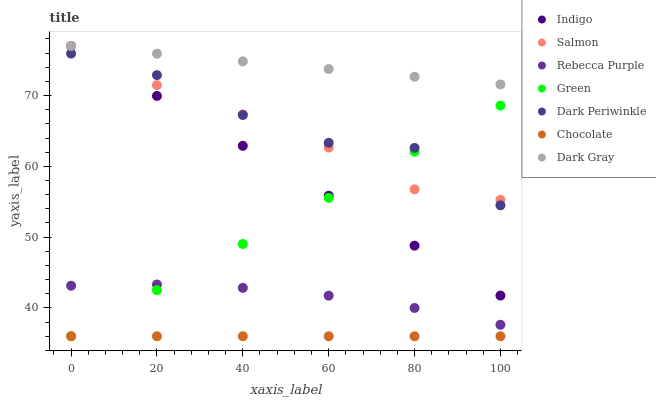Does Chocolate have the minimum area under the curve?
Answer yes or no. Yes. Does Dark Gray have the maximum area under the curve?
Answer yes or no. Yes. Does Salmon have the minimum area under the curve?
Answer yes or no. No. Does Salmon have the maximum area under the curve?
Answer yes or no. No. Is Chocolate the smoothest?
Answer yes or no. Yes. Is Dark Periwinkle the roughest?
Answer yes or no. Yes. Is Salmon the smoothest?
Answer yes or no. No. Is Salmon the roughest?
Answer yes or no. No. Does Chocolate have the lowest value?
Answer yes or no. Yes. Does Salmon have the lowest value?
Answer yes or no. No. Does Dark Gray have the highest value?
Answer yes or no. Yes. Does Chocolate have the highest value?
Answer yes or no. No. Is Chocolate less than Salmon?
Answer yes or no. Yes. Is Dark Gray greater than Chocolate?
Answer yes or no. Yes. Does Indigo intersect Salmon?
Answer yes or no. Yes. Is Indigo less than Salmon?
Answer yes or no. No. Is Indigo greater than Salmon?
Answer yes or no. No. Does Chocolate intersect Salmon?
Answer yes or no. No. 